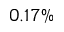<formula> <loc_0><loc_0><loc_500><loc_500>0 . 1 7 \%</formula> 